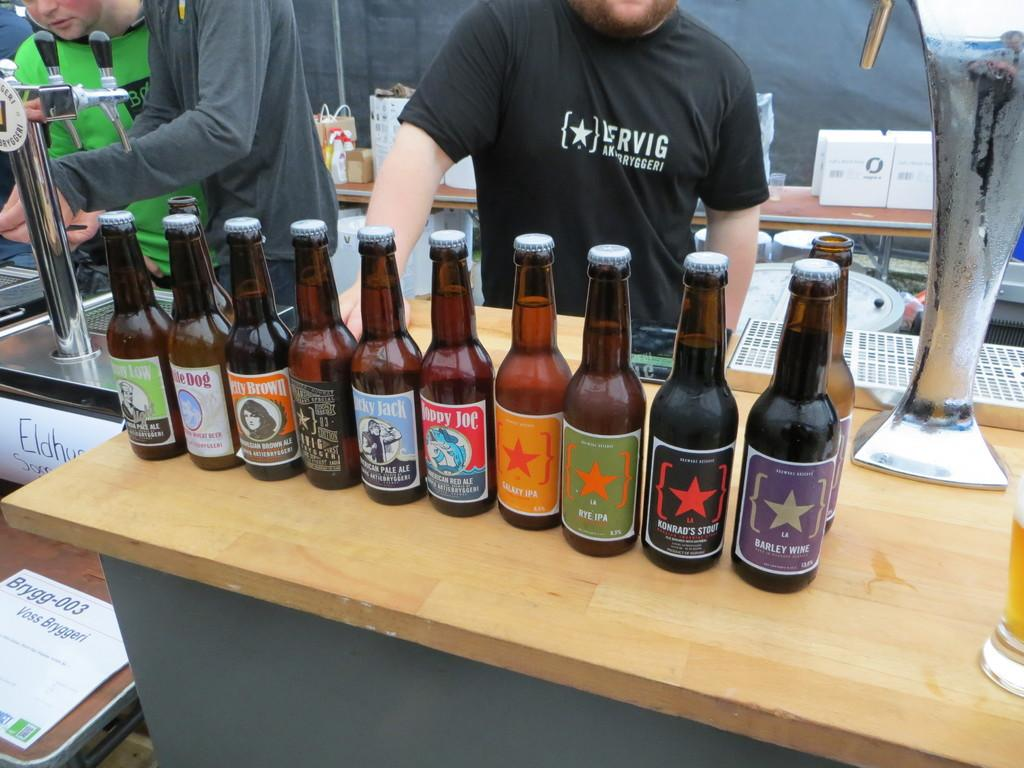Provide a one-sentence caption for the provided image. A row of lesser known beer brands include varieties such as Konrad's Stout and Barley Wine. 